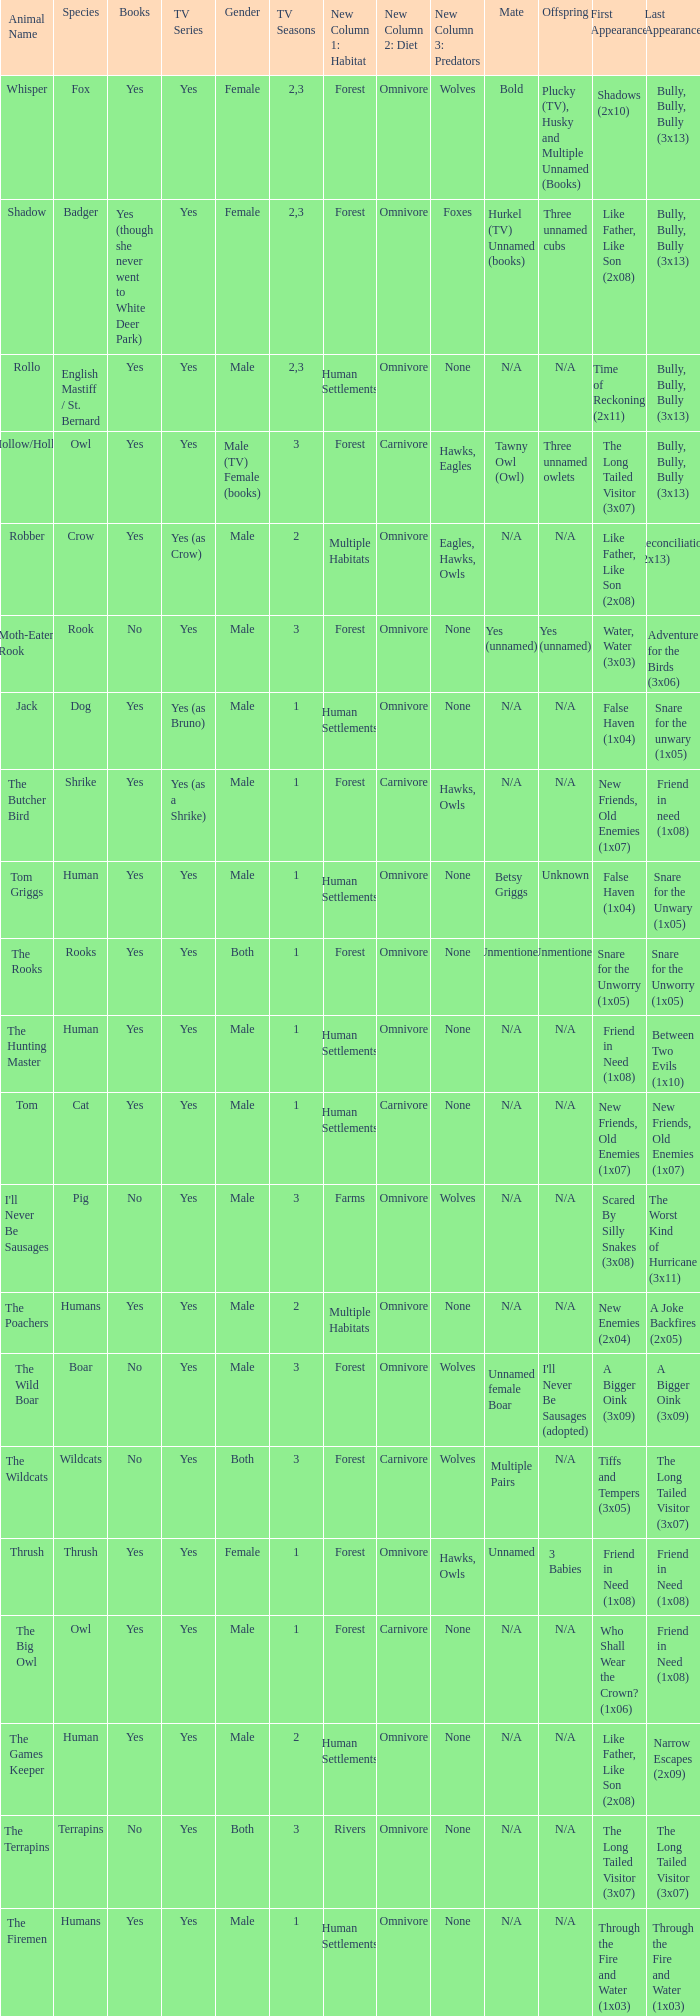What animal was yes for tv series and was a terrapins? The Terrapins. 